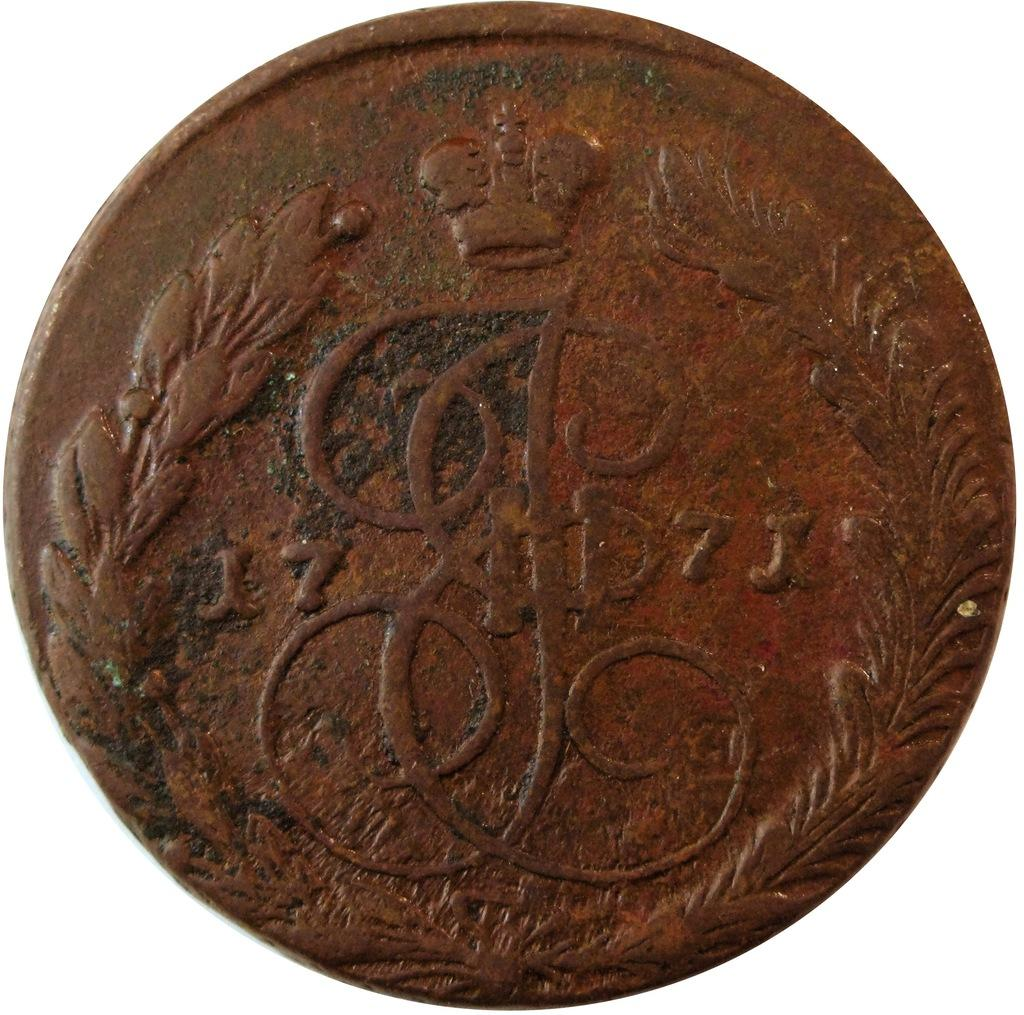What object is present in the image? There is a coin in the image. What is the shape of the coin? The coin is circular in shape. What can be found on the surface of the coin? The coin has text and a design on it. What invention is being used to create a trail in the image? There is no invention or trail present in the image; it features a coin with text and a design. What type of government is depicted on the coin in the image? There is no government depicted on the coin in the image; it only has text and a design. 